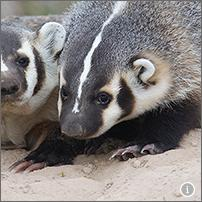Can you describe the environment these badgers are in? The environment shown around the badgers looks to be a mixture of sandy and possibly clay-rich soil, typical of habitats where they can easily dig. The lack of dense vegetation suggests a relatively open area, which might be near grasslands or sparse woodlands. This kind of environment supports their digging behavior and provides ample opportunities for hunting terrestrial invertebrates, which are likely part of their diet. What challenges might badgers face in this type of environment? In such environments, challenges might include a scarcity of water sources, exposure to predators due to the open spaces, and potentially harsh climatic conditions. Additionally, the competition for the limited food resources, especially during dry seasons, might be intense among ground-dwelling competitors. 